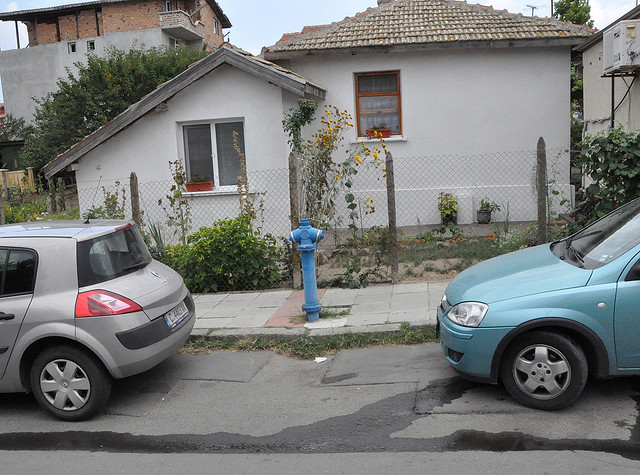<image>What is the gray and red thing used for? I am not sure what the gray and red thing is used for. It could be used for driving or transportation. What is the gray and red thing used for? I am not sure what the gray and red thing is used for. However, it seems to be related to driving or transportation. 